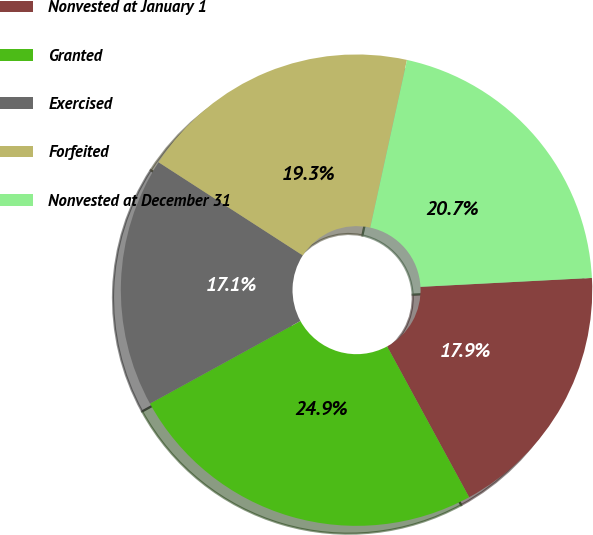<chart> <loc_0><loc_0><loc_500><loc_500><pie_chart><fcel>Nonvested at January 1<fcel>Granted<fcel>Exercised<fcel>Forfeited<fcel>Nonvested at December 31<nl><fcel>17.9%<fcel>24.93%<fcel>17.12%<fcel>19.3%<fcel>20.74%<nl></chart> 